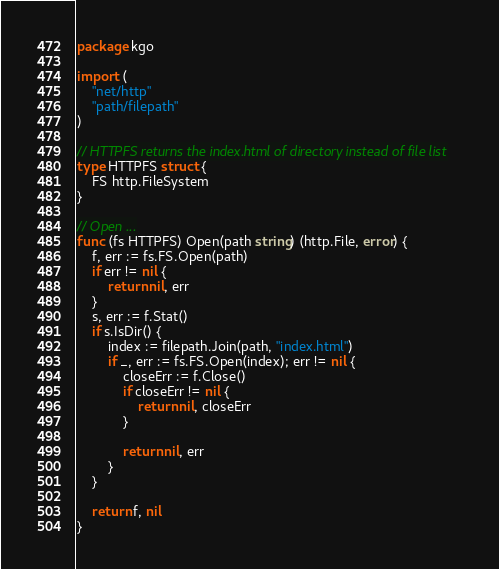<code> <loc_0><loc_0><loc_500><loc_500><_Go_>package kgo

import (
	"net/http"
	"path/filepath"
)

// HTTPFS returns the index.html of directory instead of file list
type HTTPFS struct {
	FS http.FileSystem
}

// Open ...
func (fs HTTPFS) Open(path string) (http.File, error) {
	f, err := fs.FS.Open(path)
	if err != nil {
		return nil, err
	}
	s, err := f.Stat()
	if s.IsDir() {
		index := filepath.Join(path, "index.html")
		if _, err := fs.FS.Open(index); err != nil {
			closeErr := f.Close()
			if closeErr != nil {
				return nil, closeErr
			}

			return nil, err
		}
	}

	return f, nil
}
</code> 